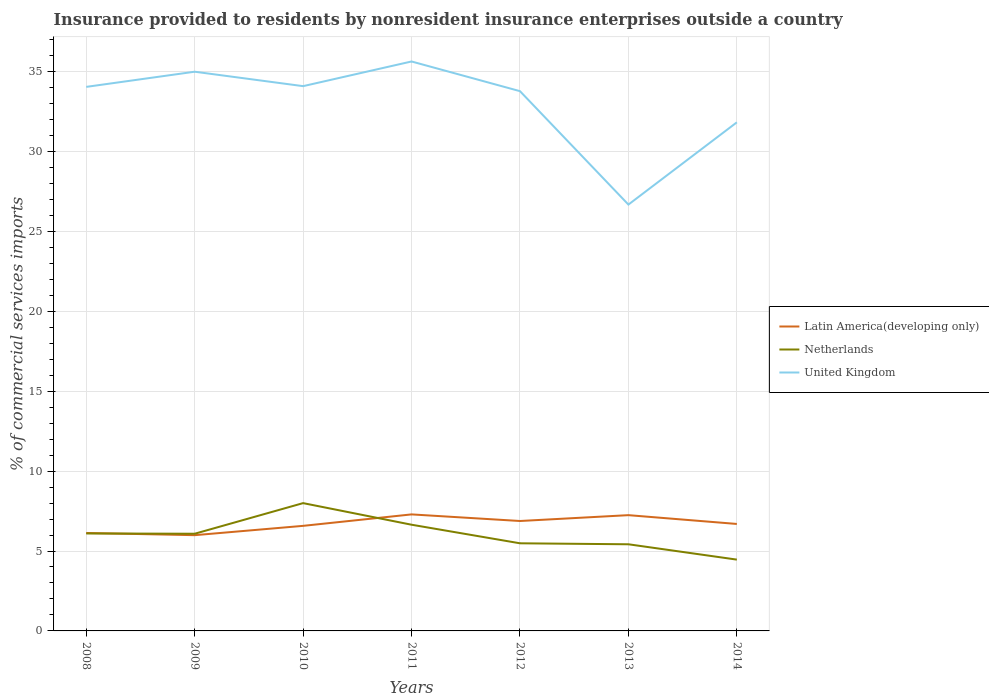Across all years, what is the maximum Insurance provided to residents in Latin America(developing only)?
Provide a short and direct response. 5.99. What is the total Insurance provided to residents in United Kingdom in the graph?
Keep it short and to the point. 8.31. What is the difference between the highest and the second highest Insurance provided to residents in Netherlands?
Ensure brevity in your answer.  3.54. How many lines are there?
Provide a succinct answer. 3. How many years are there in the graph?
Keep it short and to the point. 7. What is the difference between two consecutive major ticks on the Y-axis?
Offer a very short reply. 5. Are the values on the major ticks of Y-axis written in scientific E-notation?
Make the answer very short. No. Does the graph contain any zero values?
Your response must be concise. No. Where does the legend appear in the graph?
Your answer should be very brief. Center right. What is the title of the graph?
Your response must be concise. Insurance provided to residents by nonresident insurance enterprises outside a country. What is the label or title of the X-axis?
Give a very brief answer. Years. What is the label or title of the Y-axis?
Offer a terse response. % of commercial services imports. What is the % of commercial services imports in Latin America(developing only) in 2008?
Provide a short and direct response. 6.13. What is the % of commercial services imports in Netherlands in 2008?
Provide a succinct answer. 6.1. What is the % of commercial services imports in United Kingdom in 2008?
Provide a short and direct response. 34.04. What is the % of commercial services imports in Latin America(developing only) in 2009?
Your response must be concise. 5.99. What is the % of commercial services imports of Netherlands in 2009?
Keep it short and to the point. 6.08. What is the % of commercial services imports in United Kingdom in 2009?
Make the answer very short. 34.99. What is the % of commercial services imports in Latin America(developing only) in 2010?
Your answer should be compact. 6.57. What is the % of commercial services imports of Netherlands in 2010?
Give a very brief answer. 8. What is the % of commercial services imports of United Kingdom in 2010?
Your answer should be compact. 34.09. What is the % of commercial services imports of Latin America(developing only) in 2011?
Offer a terse response. 7.29. What is the % of commercial services imports of Netherlands in 2011?
Give a very brief answer. 6.65. What is the % of commercial services imports in United Kingdom in 2011?
Provide a succinct answer. 35.63. What is the % of commercial services imports in Latin America(developing only) in 2012?
Give a very brief answer. 6.88. What is the % of commercial services imports in Netherlands in 2012?
Provide a short and direct response. 5.48. What is the % of commercial services imports of United Kingdom in 2012?
Ensure brevity in your answer.  33.77. What is the % of commercial services imports in Latin America(developing only) in 2013?
Your response must be concise. 7.24. What is the % of commercial services imports of Netherlands in 2013?
Keep it short and to the point. 5.42. What is the % of commercial services imports of United Kingdom in 2013?
Your answer should be very brief. 26.68. What is the % of commercial services imports in Latin America(developing only) in 2014?
Provide a short and direct response. 6.69. What is the % of commercial services imports of Netherlands in 2014?
Give a very brief answer. 4.46. What is the % of commercial services imports of United Kingdom in 2014?
Provide a succinct answer. 31.82. Across all years, what is the maximum % of commercial services imports of Latin America(developing only)?
Offer a very short reply. 7.29. Across all years, what is the maximum % of commercial services imports of Netherlands?
Your response must be concise. 8. Across all years, what is the maximum % of commercial services imports of United Kingdom?
Your answer should be compact. 35.63. Across all years, what is the minimum % of commercial services imports of Latin America(developing only)?
Give a very brief answer. 5.99. Across all years, what is the minimum % of commercial services imports of Netherlands?
Your answer should be compact. 4.46. Across all years, what is the minimum % of commercial services imports in United Kingdom?
Provide a succinct answer. 26.68. What is the total % of commercial services imports of Latin America(developing only) in the graph?
Ensure brevity in your answer.  46.8. What is the total % of commercial services imports of Netherlands in the graph?
Provide a succinct answer. 42.19. What is the total % of commercial services imports in United Kingdom in the graph?
Your answer should be very brief. 231.03. What is the difference between the % of commercial services imports in Latin America(developing only) in 2008 and that in 2009?
Give a very brief answer. 0.14. What is the difference between the % of commercial services imports in Netherlands in 2008 and that in 2009?
Give a very brief answer. 0.02. What is the difference between the % of commercial services imports of United Kingdom in 2008 and that in 2009?
Keep it short and to the point. -0.95. What is the difference between the % of commercial services imports of Latin America(developing only) in 2008 and that in 2010?
Provide a short and direct response. -0.45. What is the difference between the % of commercial services imports in Netherlands in 2008 and that in 2010?
Make the answer very short. -1.9. What is the difference between the % of commercial services imports in United Kingdom in 2008 and that in 2010?
Keep it short and to the point. -0.05. What is the difference between the % of commercial services imports of Latin America(developing only) in 2008 and that in 2011?
Offer a very short reply. -1.16. What is the difference between the % of commercial services imports in Netherlands in 2008 and that in 2011?
Give a very brief answer. -0.55. What is the difference between the % of commercial services imports in United Kingdom in 2008 and that in 2011?
Ensure brevity in your answer.  -1.59. What is the difference between the % of commercial services imports of Latin America(developing only) in 2008 and that in 2012?
Give a very brief answer. -0.75. What is the difference between the % of commercial services imports in Netherlands in 2008 and that in 2012?
Your answer should be very brief. 0.61. What is the difference between the % of commercial services imports in United Kingdom in 2008 and that in 2012?
Your answer should be very brief. 0.27. What is the difference between the % of commercial services imports in Latin America(developing only) in 2008 and that in 2013?
Your answer should be very brief. -1.11. What is the difference between the % of commercial services imports of Netherlands in 2008 and that in 2013?
Keep it short and to the point. 0.68. What is the difference between the % of commercial services imports in United Kingdom in 2008 and that in 2013?
Provide a short and direct response. 7.36. What is the difference between the % of commercial services imports in Latin America(developing only) in 2008 and that in 2014?
Your answer should be compact. -0.56. What is the difference between the % of commercial services imports of Netherlands in 2008 and that in 2014?
Your response must be concise. 1.64. What is the difference between the % of commercial services imports in United Kingdom in 2008 and that in 2014?
Offer a terse response. 2.22. What is the difference between the % of commercial services imports in Latin America(developing only) in 2009 and that in 2010?
Offer a terse response. -0.58. What is the difference between the % of commercial services imports in Netherlands in 2009 and that in 2010?
Your answer should be compact. -1.92. What is the difference between the % of commercial services imports in United Kingdom in 2009 and that in 2010?
Make the answer very short. 0.9. What is the difference between the % of commercial services imports in Latin America(developing only) in 2009 and that in 2011?
Offer a very short reply. -1.3. What is the difference between the % of commercial services imports in Netherlands in 2009 and that in 2011?
Keep it short and to the point. -0.56. What is the difference between the % of commercial services imports in United Kingdom in 2009 and that in 2011?
Offer a very short reply. -0.64. What is the difference between the % of commercial services imports in Latin America(developing only) in 2009 and that in 2012?
Offer a very short reply. -0.89. What is the difference between the % of commercial services imports of Netherlands in 2009 and that in 2012?
Your answer should be compact. 0.6. What is the difference between the % of commercial services imports in United Kingdom in 2009 and that in 2012?
Keep it short and to the point. 1.22. What is the difference between the % of commercial services imports of Latin America(developing only) in 2009 and that in 2013?
Your response must be concise. -1.25. What is the difference between the % of commercial services imports in Netherlands in 2009 and that in 2013?
Make the answer very short. 0.66. What is the difference between the % of commercial services imports in United Kingdom in 2009 and that in 2013?
Provide a succinct answer. 8.31. What is the difference between the % of commercial services imports of Latin America(developing only) in 2009 and that in 2014?
Your answer should be very brief. -0.7. What is the difference between the % of commercial services imports of Netherlands in 2009 and that in 2014?
Give a very brief answer. 1.62. What is the difference between the % of commercial services imports of United Kingdom in 2009 and that in 2014?
Offer a very short reply. 3.17. What is the difference between the % of commercial services imports in Latin America(developing only) in 2010 and that in 2011?
Ensure brevity in your answer.  -0.72. What is the difference between the % of commercial services imports in Netherlands in 2010 and that in 2011?
Offer a terse response. 1.35. What is the difference between the % of commercial services imports in United Kingdom in 2010 and that in 2011?
Offer a very short reply. -1.54. What is the difference between the % of commercial services imports in Latin America(developing only) in 2010 and that in 2012?
Offer a very short reply. -0.3. What is the difference between the % of commercial services imports in Netherlands in 2010 and that in 2012?
Ensure brevity in your answer.  2.51. What is the difference between the % of commercial services imports in United Kingdom in 2010 and that in 2012?
Offer a very short reply. 0.31. What is the difference between the % of commercial services imports in Latin America(developing only) in 2010 and that in 2013?
Offer a terse response. -0.67. What is the difference between the % of commercial services imports of Netherlands in 2010 and that in 2013?
Your response must be concise. 2.58. What is the difference between the % of commercial services imports in United Kingdom in 2010 and that in 2013?
Keep it short and to the point. 7.41. What is the difference between the % of commercial services imports of Latin America(developing only) in 2010 and that in 2014?
Offer a very short reply. -0.12. What is the difference between the % of commercial services imports in Netherlands in 2010 and that in 2014?
Your response must be concise. 3.54. What is the difference between the % of commercial services imports in United Kingdom in 2010 and that in 2014?
Ensure brevity in your answer.  2.26. What is the difference between the % of commercial services imports in Latin America(developing only) in 2011 and that in 2012?
Keep it short and to the point. 0.41. What is the difference between the % of commercial services imports of Netherlands in 2011 and that in 2012?
Offer a very short reply. 1.16. What is the difference between the % of commercial services imports in United Kingdom in 2011 and that in 2012?
Provide a short and direct response. 1.86. What is the difference between the % of commercial services imports of Latin America(developing only) in 2011 and that in 2013?
Provide a short and direct response. 0.05. What is the difference between the % of commercial services imports in Netherlands in 2011 and that in 2013?
Provide a succinct answer. 1.22. What is the difference between the % of commercial services imports of United Kingdom in 2011 and that in 2013?
Provide a short and direct response. 8.95. What is the difference between the % of commercial services imports in Latin America(developing only) in 2011 and that in 2014?
Provide a short and direct response. 0.6. What is the difference between the % of commercial services imports in Netherlands in 2011 and that in 2014?
Provide a short and direct response. 2.18. What is the difference between the % of commercial services imports in United Kingdom in 2011 and that in 2014?
Your response must be concise. 3.81. What is the difference between the % of commercial services imports in Latin America(developing only) in 2012 and that in 2013?
Ensure brevity in your answer.  -0.37. What is the difference between the % of commercial services imports of Netherlands in 2012 and that in 2013?
Provide a succinct answer. 0.06. What is the difference between the % of commercial services imports in United Kingdom in 2012 and that in 2013?
Offer a very short reply. 7.1. What is the difference between the % of commercial services imports in Latin America(developing only) in 2012 and that in 2014?
Offer a very short reply. 0.19. What is the difference between the % of commercial services imports in Netherlands in 2012 and that in 2014?
Ensure brevity in your answer.  1.02. What is the difference between the % of commercial services imports of United Kingdom in 2012 and that in 2014?
Your response must be concise. 1.95. What is the difference between the % of commercial services imports in Latin America(developing only) in 2013 and that in 2014?
Provide a succinct answer. 0.55. What is the difference between the % of commercial services imports of Netherlands in 2013 and that in 2014?
Keep it short and to the point. 0.96. What is the difference between the % of commercial services imports in United Kingdom in 2013 and that in 2014?
Make the answer very short. -5.15. What is the difference between the % of commercial services imports in Latin America(developing only) in 2008 and the % of commercial services imports in Netherlands in 2009?
Keep it short and to the point. 0.05. What is the difference between the % of commercial services imports of Latin America(developing only) in 2008 and the % of commercial services imports of United Kingdom in 2009?
Make the answer very short. -28.86. What is the difference between the % of commercial services imports of Netherlands in 2008 and the % of commercial services imports of United Kingdom in 2009?
Offer a very short reply. -28.89. What is the difference between the % of commercial services imports in Latin America(developing only) in 2008 and the % of commercial services imports in Netherlands in 2010?
Provide a short and direct response. -1.87. What is the difference between the % of commercial services imports in Latin America(developing only) in 2008 and the % of commercial services imports in United Kingdom in 2010?
Your response must be concise. -27.96. What is the difference between the % of commercial services imports of Netherlands in 2008 and the % of commercial services imports of United Kingdom in 2010?
Provide a succinct answer. -27.99. What is the difference between the % of commercial services imports in Latin America(developing only) in 2008 and the % of commercial services imports in Netherlands in 2011?
Keep it short and to the point. -0.52. What is the difference between the % of commercial services imports in Latin America(developing only) in 2008 and the % of commercial services imports in United Kingdom in 2011?
Keep it short and to the point. -29.5. What is the difference between the % of commercial services imports of Netherlands in 2008 and the % of commercial services imports of United Kingdom in 2011?
Ensure brevity in your answer.  -29.53. What is the difference between the % of commercial services imports in Latin America(developing only) in 2008 and the % of commercial services imports in Netherlands in 2012?
Make the answer very short. 0.65. What is the difference between the % of commercial services imports in Latin America(developing only) in 2008 and the % of commercial services imports in United Kingdom in 2012?
Ensure brevity in your answer.  -27.65. What is the difference between the % of commercial services imports in Netherlands in 2008 and the % of commercial services imports in United Kingdom in 2012?
Offer a terse response. -27.68. What is the difference between the % of commercial services imports in Latin America(developing only) in 2008 and the % of commercial services imports in Netherlands in 2013?
Offer a very short reply. 0.71. What is the difference between the % of commercial services imports in Latin America(developing only) in 2008 and the % of commercial services imports in United Kingdom in 2013?
Your answer should be very brief. -20.55. What is the difference between the % of commercial services imports in Netherlands in 2008 and the % of commercial services imports in United Kingdom in 2013?
Your answer should be compact. -20.58. What is the difference between the % of commercial services imports in Latin America(developing only) in 2008 and the % of commercial services imports in Netherlands in 2014?
Your answer should be very brief. 1.67. What is the difference between the % of commercial services imports in Latin America(developing only) in 2008 and the % of commercial services imports in United Kingdom in 2014?
Keep it short and to the point. -25.7. What is the difference between the % of commercial services imports of Netherlands in 2008 and the % of commercial services imports of United Kingdom in 2014?
Offer a very short reply. -25.73. What is the difference between the % of commercial services imports of Latin America(developing only) in 2009 and the % of commercial services imports of Netherlands in 2010?
Make the answer very short. -2.01. What is the difference between the % of commercial services imports of Latin America(developing only) in 2009 and the % of commercial services imports of United Kingdom in 2010?
Ensure brevity in your answer.  -28.1. What is the difference between the % of commercial services imports in Netherlands in 2009 and the % of commercial services imports in United Kingdom in 2010?
Keep it short and to the point. -28.01. What is the difference between the % of commercial services imports in Latin America(developing only) in 2009 and the % of commercial services imports in Netherlands in 2011?
Provide a succinct answer. -0.65. What is the difference between the % of commercial services imports in Latin America(developing only) in 2009 and the % of commercial services imports in United Kingdom in 2011?
Your response must be concise. -29.64. What is the difference between the % of commercial services imports of Netherlands in 2009 and the % of commercial services imports of United Kingdom in 2011?
Offer a terse response. -29.55. What is the difference between the % of commercial services imports of Latin America(developing only) in 2009 and the % of commercial services imports of Netherlands in 2012?
Your answer should be compact. 0.51. What is the difference between the % of commercial services imports of Latin America(developing only) in 2009 and the % of commercial services imports of United Kingdom in 2012?
Your answer should be very brief. -27.78. What is the difference between the % of commercial services imports in Netherlands in 2009 and the % of commercial services imports in United Kingdom in 2012?
Keep it short and to the point. -27.69. What is the difference between the % of commercial services imports in Latin America(developing only) in 2009 and the % of commercial services imports in Netherlands in 2013?
Keep it short and to the point. 0.57. What is the difference between the % of commercial services imports in Latin America(developing only) in 2009 and the % of commercial services imports in United Kingdom in 2013?
Give a very brief answer. -20.69. What is the difference between the % of commercial services imports in Netherlands in 2009 and the % of commercial services imports in United Kingdom in 2013?
Offer a terse response. -20.6. What is the difference between the % of commercial services imports in Latin America(developing only) in 2009 and the % of commercial services imports in Netherlands in 2014?
Provide a short and direct response. 1.53. What is the difference between the % of commercial services imports in Latin America(developing only) in 2009 and the % of commercial services imports in United Kingdom in 2014?
Provide a succinct answer. -25.83. What is the difference between the % of commercial services imports of Netherlands in 2009 and the % of commercial services imports of United Kingdom in 2014?
Keep it short and to the point. -25.74. What is the difference between the % of commercial services imports in Latin America(developing only) in 2010 and the % of commercial services imports in Netherlands in 2011?
Your answer should be very brief. -0.07. What is the difference between the % of commercial services imports of Latin America(developing only) in 2010 and the % of commercial services imports of United Kingdom in 2011?
Your answer should be very brief. -29.06. What is the difference between the % of commercial services imports in Netherlands in 2010 and the % of commercial services imports in United Kingdom in 2011?
Keep it short and to the point. -27.64. What is the difference between the % of commercial services imports of Latin America(developing only) in 2010 and the % of commercial services imports of Netherlands in 2012?
Give a very brief answer. 1.09. What is the difference between the % of commercial services imports of Latin America(developing only) in 2010 and the % of commercial services imports of United Kingdom in 2012?
Your response must be concise. -27.2. What is the difference between the % of commercial services imports of Netherlands in 2010 and the % of commercial services imports of United Kingdom in 2012?
Offer a very short reply. -25.78. What is the difference between the % of commercial services imports of Latin America(developing only) in 2010 and the % of commercial services imports of Netherlands in 2013?
Your answer should be compact. 1.15. What is the difference between the % of commercial services imports in Latin America(developing only) in 2010 and the % of commercial services imports in United Kingdom in 2013?
Ensure brevity in your answer.  -20.1. What is the difference between the % of commercial services imports of Netherlands in 2010 and the % of commercial services imports of United Kingdom in 2013?
Keep it short and to the point. -18.68. What is the difference between the % of commercial services imports of Latin America(developing only) in 2010 and the % of commercial services imports of Netherlands in 2014?
Your answer should be very brief. 2.11. What is the difference between the % of commercial services imports of Latin America(developing only) in 2010 and the % of commercial services imports of United Kingdom in 2014?
Ensure brevity in your answer.  -25.25. What is the difference between the % of commercial services imports in Netherlands in 2010 and the % of commercial services imports in United Kingdom in 2014?
Your answer should be compact. -23.83. What is the difference between the % of commercial services imports of Latin America(developing only) in 2011 and the % of commercial services imports of Netherlands in 2012?
Keep it short and to the point. 1.81. What is the difference between the % of commercial services imports of Latin America(developing only) in 2011 and the % of commercial services imports of United Kingdom in 2012?
Ensure brevity in your answer.  -26.48. What is the difference between the % of commercial services imports in Netherlands in 2011 and the % of commercial services imports in United Kingdom in 2012?
Make the answer very short. -27.13. What is the difference between the % of commercial services imports of Latin America(developing only) in 2011 and the % of commercial services imports of Netherlands in 2013?
Offer a terse response. 1.87. What is the difference between the % of commercial services imports in Latin America(developing only) in 2011 and the % of commercial services imports in United Kingdom in 2013?
Provide a succinct answer. -19.39. What is the difference between the % of commercial services imports in Netherlands in 2011 and the % of commercial services imports in United Kingdom in 2013?
Provide a short and direct response. -20.03. What is the difference between the % of commercial services imports of Latin America(developing only) in 2011 and the % of commercial services imports of Netherlands in 2014?
Your response must be concise. 2.83. What is the difference between the % of commercial services imports of Latin America(developing only) in 2011 and the % of commercial services imports of United Kingdom in 2014?
Give a very brief answer. -24.53. What is the difference between the % of commercial services imports of Netherlands in 2011 and the % of commercial services imports of United Kingdom in 2014?
Make the answer very short. -25.18. What is the difference between the % of commercial services imports of Latin America(developing only) in 2012 and the % of commercial services imports of Netherlands in 2013?
Provide a succinct answer. 1.46. What is the difference between the % of commercial services imports of Latin America(developing only) in 2012 and the % of commercial services imports of United Kingdom in 2013?
Your response must be concise. -19.8. What is the difference between the % of commercial services imports in Netherlands in 2012 and the % of commercial services imports in United Kingdom in 2013?
Provide a short and direct response. -21.2. What is the difference between the % of commercial services imports of Latin America(developing only) in 2012 and the % of commercial services imports of Netherlands in 2014?
Make the answer very short. 2.42. What is the difference between the % of commercial services imports in Latin America(developing only) in 2012 and the % of commercial services imports in United Kingdom in 2014?
Your answer should be compact. -24.95. What is the difference between the % of commercial services imports of Netherlands in 2012 and the % of commercial services imports of United Kingdom in 2014?
Ensure brevity in your answer.  -26.34. What is the difference between the % of commercial services imports of Latin America(developing only) in 2013 and the % of commercial services imports of Netherlands in 2014?
Ensure brevity in your answer.  2.78. What is the difference between the % of commercial services imports of Latin America(developing only) in 2013 and the % of commercial services imports of United Kingdom in 2014?
Make the answer very short. -24.58. What is the difference between the % of commercial services imports in Netherlands in 2013 and the % of commercial services imports in United Kingdom in 2014?
Make the answer very short. -26.4. What is the average % of commercial services imports of Latin America(developing only) per year?
Make the answer very short. 6.69. What is the average % of commercial services imports in Netherlands per year?
Give a very brief answer. 6.03. What is the average % of commercial services imports of United Kingdom per year?
Your response must be concise. 33. In the year 2008, what is the difference between the % of commercial services imports in Latin America(developing only) and % of commercial services imports in Netherlands?
Offer a very short reply. 0.03. In the year 2008, what is the difference between the % of commercial services imports of Latin America(developing only) and % of commercial services imports of United Kingdom?
Provide a short and direct response. -27.91. In the year 2008, what is the difference between the % of commercial services imports in Netherlands and % of commercial services imports in United Kingdom?
Your answer should be very brief. -27.95. In the year 2009, what is the difference between the % of commercial services imports of Latin America(developing only) and % of commercial services imports of Netherlands?
Your response must be concise. -0.09. In the year 2009, what is the difference between the % of commercial services imports in Latin America(developing only) and % of commercial services imports in United Kingdom?
Make the answer very short. -29. In the year 2009, what is the difference between the % of commercial services imports of Netherlands and % of commercial services imports of United Kingdom?
Offer a very short reply. -28.91. In the year 2010, what is the difference between the % of commercial services imports of Latin America(developing only) and % of commercial services imports of Netherlands?
Make the answer very short. -1.42. In the year 2010, what is the difference between the % of commercial services imports in Latin America(developing only) and % of commercial services imports in United Kingdom?
Make the answer very short. -27.51. In the year 2010, what is the difference between the % of commercial services imports of Netherlands and % of commercial services imports of United Kingdom?
Keep it short and to the point. -26.09. In the year 2011, what is the difference between the % of commercial services imports of Latin America(developing only) and % of commercial services imports of Netherlands?
Keep it short and to the point. 0.65. In the year 2011, what is the difference between the % of commercial services imports in Latin America(developing only) and % of commercial services imports in United Kingdom?
Provide a succinct answer. -28.34. In the year 2011, what is the difference between the % of commercial services imports of Netherlands and % of commercial services imports of United Kingdom?
Offer a terse response. -28.99. In the year 2012, what is the difference between the % of commercial services imports in Latin America(developing only) and % of commercial services imports in Netherlands?
Your answer should be very brief. 1.4. In the year 2012, what is the difference between the % of commercial services imports in Latin America(developing only) and % of commercial services imports in United Kingdom?
Your response must be concise. -26.9. In the year 2012, what is the difference between the % of commercial services imports of Netherlands and % of commercial services imports of United Kingdom?
Offer a terse response. -28.29. In the year 2013, what is the difference between the % of commercial services imports in Latin America(developing only) and % of commercial services imports in Netherlands?
Your answer should be compact. 1.82. In the year 2013, what is the difference between the % of commercial services imports in Latin America(developing only) and % of commercial services imports in United Kingdom?
Your answer should be very brief. -19.43. In the year 2013, what is the difference between the % of commercial services imports in Netherlands and % of commercial services imports in United Kingdom?
Your answer should be compact. -21.26. In the year 2014, what is the difference between the % of commercial services imports in Latin America(developing only) and % of commercial services imports in Netherlands?
Your answer should be very brief. 2.23. In the year 2014, what is the difference between the % of commercial services imports in Latin America(developing only) and % of commercial services imports in United Kingdom?
Offer a very short reply. -25.13. In the year 2014, what is the difference between the % of commercial services imports of Netherlands and % of commercial services imports of United Kingdom?
Offer a terse response. -27.36. What is the ratio of the % of commercial services imports in Latin America(developing only) in 2008 to that in 2009?
Keep it short and to the point. 1.02. What is the ratio of the % of commercial services imports in United Kingdom in 2008 to that in 2009?
Provide a succinct answer. 0.97. What is the ratio of the % of commercial services imports in Latin America(developing only) in 2008 to that in 2010?
Provide a succinct answer. 0.93. What is the ratio of the % of commercial services imports of Netherlands in 2008 to that in 2010?
Ensure brevity in your answer.  0.76. What is the ratio of the % of commercial services imports in United Kingdom in 2008 to that in 2010?
Your answer should be compact. 1. What is the ratio of the % of commercial services imports of Latin America(developing only) in 2008 to that in 2011?
Give a very brief answer. 0.84. What is the ratio of the % of commercial services imports in Netherlands in 2008 to that in 2011?
Provide a succinct answer. 0.92. What is the ratio of the % of commercial services imports of United Kingdom in 2008 to that in 2011?
Give a very brief answer. 0.96. What is the ratio of the % of commercial services imports of Latin America(developing only) in 2008 to that in 2012?
Your answer should be very brief. 0.89. What is the ratio of the % of commercial services imports of Netherlands in 2008 to that in 2012?
Provide a short and direct response. 1.11. What is the ratio of the % of commercial services imports of United Kingdom in 2008 to that in 2012?
Your response must be concise. 1.01. What is the ratio of the % of commercial services imports in Latin America(developing only) in 2008 to that in 2013?
Provide a short and direct response. 0.85. What is the ratio of the % of commercial services imports of Netherlands in 2008 to that in 2013?
Offer a very short reply. 1.12. What is the ratio of the % of commercial services imports of United Kingdom in 2008 to that in 2013?
Your answer should be compact. 1.28. What is the ratio of the % of commercial services imports of Latin America(developing only) in 2008 to that in 2014?
Your answer should be very brief. 0.92. What is the ratio of the % of commercial services imports of Netherlands in 2008 to that in 2014?
Provide a short and direct response. 1.37. What is the ratio of the % of commercial services imports of United Kingdom in 2008 to that in 2014?
Provide a short and direct response. 1.07. What is the ratio of the % of commercial services imports of Latin America(developing only) in 2009 to that in 2010?
Your answer should be very brief. 0.91. What is the ratio of the % of commercial services imports of Netherlands in 2009 to that in 2010?
Offer a very short reply. 0.76. What is the ratio of the % of commercial services imports of United Kingdom in 2009 to that in 2010?
Keep it short and to the point. 1.03. What is the ratio of the % of commercial services imports in Latin America(developing only) in 2009 to that in 2011?
Give a very brief answer. 0.82. What is the ratio of the % of commercial services imports of Netherlands in 2009 to that in 2011?
Your answer should be compact. 0.92. What is the ratio of the % of commercial services imports of Latin America(developing only) in 2009 to that in 2012?
Your answer should be compact. 0.87. What is the ratio of the % of commercial services imports of Netherlands in 2009 to that in 2012?
Give a very brief answer. 1.11. What is the ratio of the % of commercial services imports in United Kingdom in 2009 to that in 2012?
Ensure brevity in your answer.  1.04. What is the ratio of the % of commercial services imports in Latin America(developing only) in 2009 to that in 2013?
Offer a terse response. 0.83. What is the ratio of the % of commercial services imports in Netherlands in 2009 to that in 2013?
Your answer should be very brief. 1.12. What is the ratio of the % of commercial services imports in United Kingdom in 2009 to that in 2013?
Your response must be concise. 1.31. What is the ratio of the % of commercial services imports of Latin America(developing only) in 2009 to that in 2014?
Your answer should be compact. 0.9. What is the ratio of the % of commercial services imports in Netherlands in 2009 to that in 2014?
Your answer should be compact. 1.36. What is the ratio of the % of commercial services imports of United Kingdom in 2009 to that in 2014?
Make the answer very short. 1.1. What is the ratio of the % of commercial services imports of Latin America(developing only) in 2010 to that in 2011?
Provide a succinct answer. 0.9. What is the ratio of the % of commercial services imports of Netherlands in 2010 to that in 2011?
Your answer should be compact. 1.2. What is the ratio of the % of commercial services imports of United Kingdom in 2010 to that in 2011?
Offer a very short reply. 0.96. What is the ratio of the % of commercial services imports of Latin America(developing only) in 2010 to that in 2012?
Provide a succinct answer. 0.96. What is the ratio of the % of commercial services imports in Netherlands in 2010 to that in 2012?
Your answer should be very brief. 1.46. What is the ratio of the % of commercial services imports of United Kingdom in 2010 to that in 2012?
Offer a terse response. 1.01. What is the ratio of the % of commercial services imports in Latin America(developing only) in 2010 to that in 2013?
Ensure brevity in your answer.  0.91. What is the ratio of the % of commercial services imports of Netherlands in 2010 to that in 2013?
Your answer should be very brief. 1.48. What is the ratio of the % of commercial services imports of United Kingdom in 2010 to that in 2013?
Provide a short and direct response. 1.28. What is the ratio of the % of commercial services imports of Latin America(developing only) in 2010 to that in 2014?
Your answer should be very brief. 0.98. What is the ratio of the % of commercial services imports of Netherlands in 2010 to that in 2014?
Your answer should be compact. 1.79. What is the ratio of the % of commercial services imports in United Kingdom in 2010 to that in 2014?
Make the answer very short. 1.07. What is the ratio of the % of commercial services imports of Latin America(developing only) in 2011 to that in 2012?
Your answer should be compact. 1.06. What is the ratio of the % of commercial services imports of Netherlands in 2011 to that in 2012?
Ensure brevity in your answer.  1.21. What is the ratio of the % of commercial services imports in United Kingdom in 2011 to that in 2012?
Offer a terse response. 1.05. What is the ratio of the % of commercial services imports in Netherlands in 2011 to that in 2013?
Offer a very short reply. 1.23. What is the ratio of the % of commercial services imports of United Kingdom in 2011 to that in 2013?
Your response must be concise. 1.34. What is the ratio of the % of commercial services imports in Latin America(developing only) in 2011 to that in 2014?
Keep it short and to the point. 1.09. What is the ratio of the % of commercial services imports of Netherlands in 2011 to that in 2014?
Your response must be concise. 1.49. What is the ratio of the % of commercial services imports in United Kingdom in 2011 to that in 2014?
Offer a very short reply. 1.12. What is the ratio of the % of commercial services imports in Latin America(developing only) in 2012 to that in 2013?
Provide a short and direct response. 0.95. What is the ratio of the % of commercial services imports in Netherlands in 2012 to that in 2013?
Keep it short and to the point. 1.01. What is the ratio of the % of commercial services imports of United Kingdom in 2012 to that in 2013?
Keep it short and to the point. 1.27. What is the ratio of the % of commercial services imports in Latin America(developing only) in 2012 to that in 2014?
Make the answer very short. 1.03. What is the ratio of the % of commercial services imports of Netherlands in 2012 to that in 2014?
Offer a terse response. 1.23. What is the ratio of the % of commercial services imports in United Kingdom in 2012 to that in 2014?
Ensure brevity in your answer.  1.06. What is the ratio of the % of commercial services imports of Latin America(developing only) in 2013 to that in 2014?
Your answer should be compact. 1.08. What is the ratio of the % of commercial services imports in Netherlands in 2013 to that in 2014?
Ensure brevity in your answer.  1.22. What is the ratio of the % of commercial services imports of United Kingdom in 2013 to that in 2014?
Make the answer very short. 0.84. What is the difference between the highest and the second highest % of commercial services imports in Latin America(developing only)?
Provide a short and direct response. 0.05. What is the difference between the highest and the second highest % of commercial services imports in Netherlands?
Keep it short and to the point. 1.35. What is the difference between the highest and the second highest % of commercial services imports of United Kingdom?
Ensure brevity in your answer.  0.64. What is the difference between the highest and the lowest % of commercial services imports in Latin America(developing only)?
Keep it short and to the point. 1.3. What is the difference between the highest and the lowest % of commercial services imports of Netherlands?
Ensure brevity in your answer.  3.54. What is the difference between the highest and the lowest % of commercial services imports of United Kingdom?
Your answer should be very brief. 8.95. 